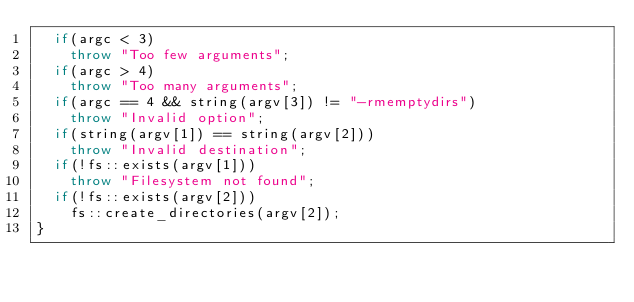<code> <loc_0><loc_0><loc_500><loc_500><_C++_>	if(argc < 3)
		throw "Too few arguments";
	if(argc > 4)
		throw "Too many arguments";
	if(argc == 4 && string(argv[3]) != "-rmemptydirs")
		throw "Invalid option";
	if(string(argv[1]) == string(argv[2]))
		throw "Invalid destination";
	if(!fs::exists(argv[1]))
		throw "Filesystem not found";
	if(!fs::exists(argv[2]))
		fs::create_directories(argv[2]);
}</code> 